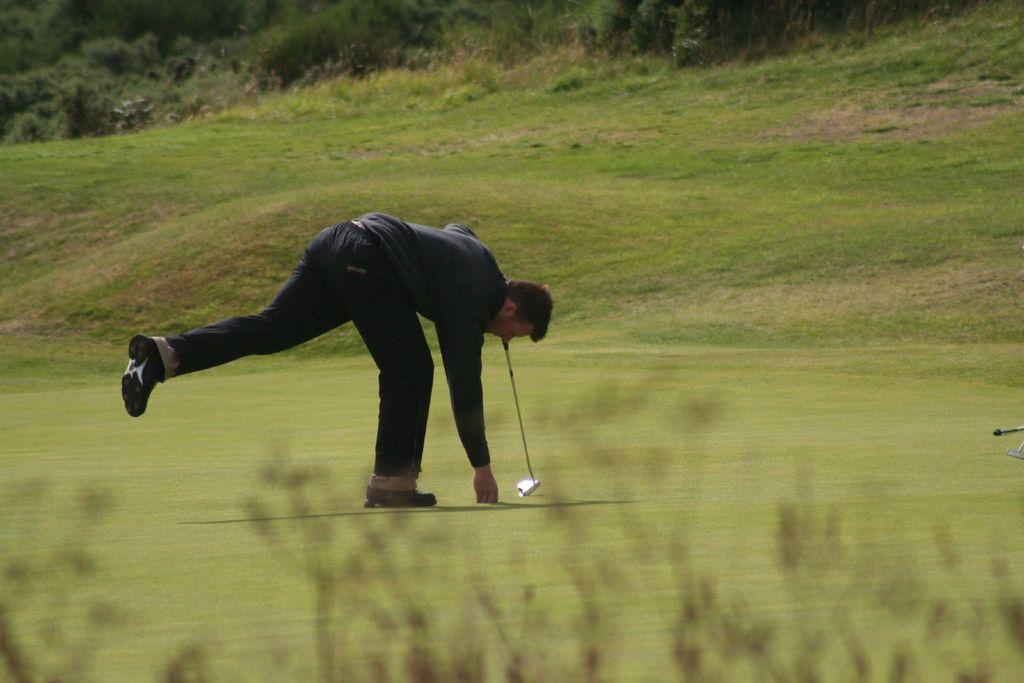How would you summarize this image in a sentence or two? In this image we can see there is a person standing on the ground and holding a golf stick. And there is are trees and grass. 